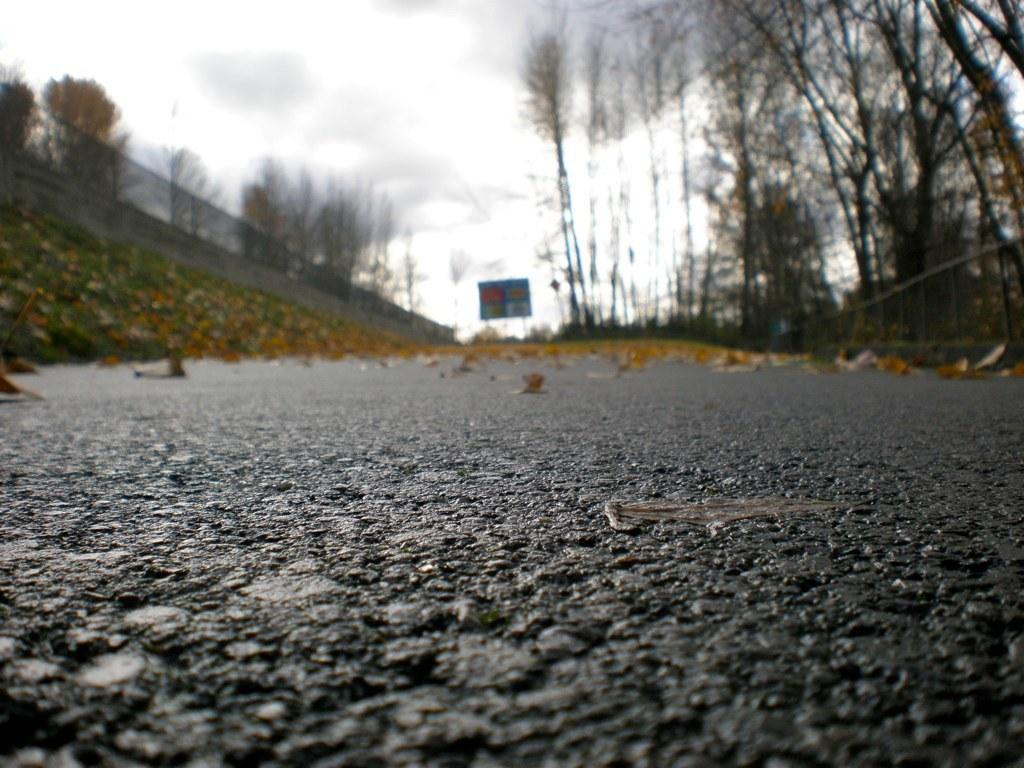What type of road is visible in the image? There is a black color tar road in the image. What is placed on the tar road? There is a banner on the tar road. What can be seen in the background of the image? There is a boundary wall with fencing grill in the background. What type of vegetation is on the right side of the image? There are dry trees on the right side of the image. What type of record is being played on the tar road in the image? There is no record being played in the image; it only features a tar road, a banner, a boundary wall with fencing grill, and dry trees. 